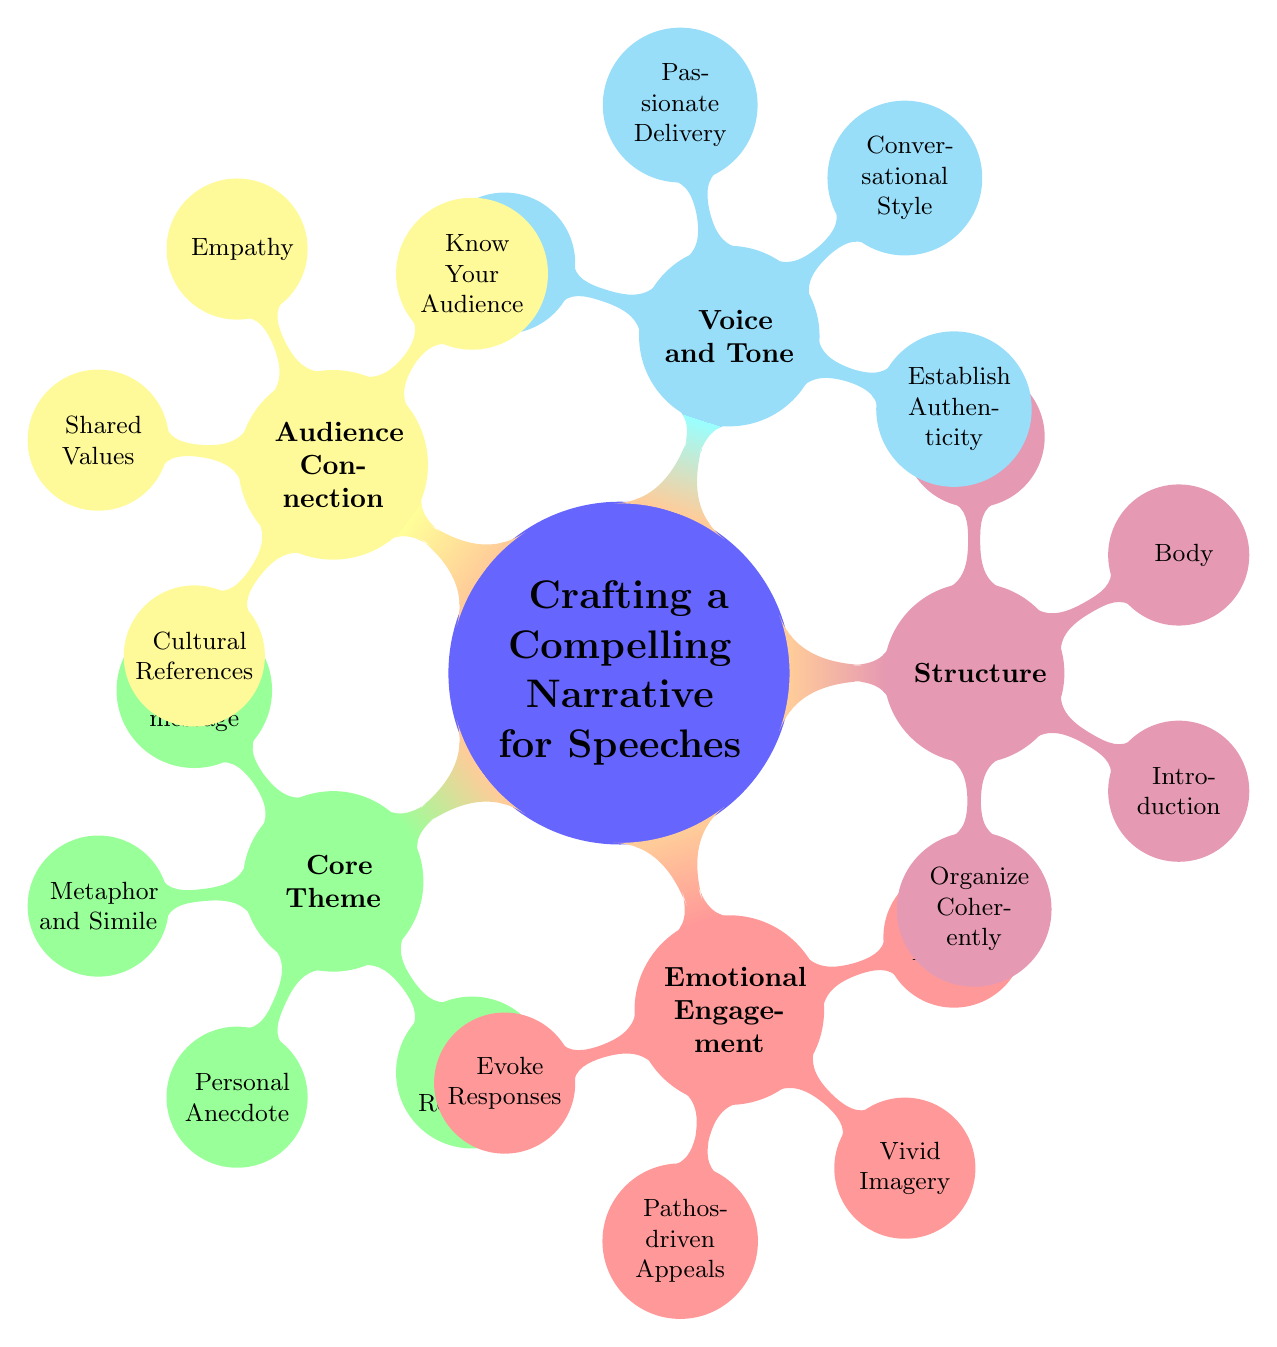What is the core theme of the mind map? The core theme is prominently labeled at the center of the mind map, and reading from the node directly reveals that it is "Crafting a Compelling Narrative for Speeches."
Answer: Crafting a Compelling Narrative for Speeches How many main categories are identified in the mind map? By counting the primary branches extending from the central node, we find there are five main categories labeled Core Theme, Emotional Engagement, Structure, Voice and Tone, and Audience Connection.
Answer: 5 What principle is associated with Emotional Engagement? Within the Emotional Engagement category, the principle is specified as "Evoke Emotional Responses," which can be directly seen in the corresponding node.
Answer: Evoke Emotional Responses Which technique is suggested for establishing authenticity in voice and tone? The strategies listed under Voice and Tone indicate "Conversational Style" as one of the techniques to establish authenticity, which can be directly verified in the diagram.
Answer: Conversational Style What are the three elements listed under Structure? The Structure category includes three clearly defined elements: "Introduction," "Body," and "Conclusion," which are found as sub-nodes under the Structure node.
Answer: Introduction, Body, Conclusion Which approaches are suggested for connecting with the audience? It can be seen in the Audience Connection category that three approaches are recommended: "Empathy," "Shared Values," and "Cultural References," all of which are visible as sub-nodes.
Answer: Empathy, Shared Values, Cultural References How does the number of techniques in Core Theme compare to techniques in Emotional Engagement? The Core Theme has three techniques: "Metaphor and Simile," "Personal Anecdote," and "Historical Reference." The Emotional Engagement, in comparison, has three techniques as well: "Pathos-driven Appeals," "Vivid Imagery," and "Poetic Devices." Since both categories contain the same number of techniques, we establish that they are equal.
Answer: Equal What is the relationship between Emotional Engagement and Audience Connection in the context of the diagram? Emotional Engagement and Audience Connection are both listed as primary categories branching out from the central theme. They do not have direct relationships with each other by way of sub-nodes, but both contribute to the overarching goal of crafting compelling narratives. Thus, while they are separate, they collectively enhance the overall narrative impact.
Answer: Separate yet interconnected What color is used for the Voice and Tone category? The node representing Voice and Tone is distinctly colored in cyan, easily identified by observing the color coding assigned in the mind map.
Answer: Cyan 